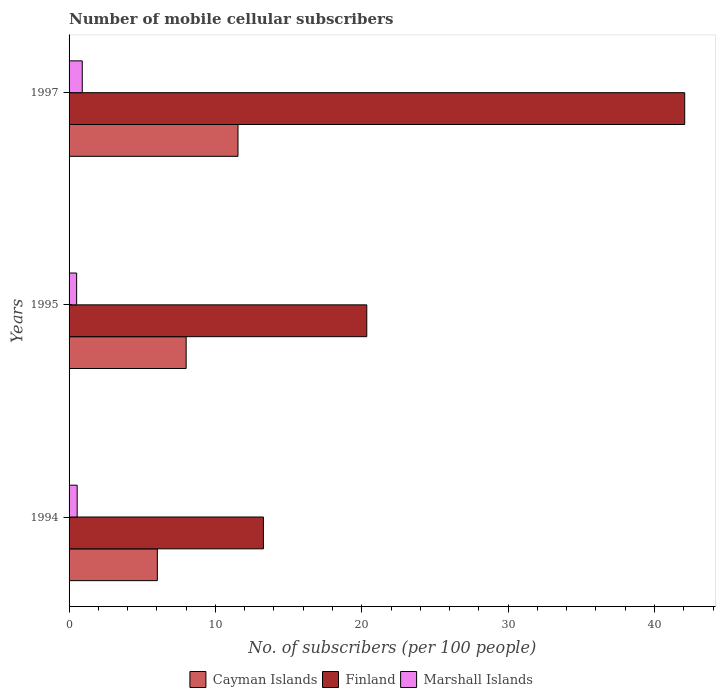Are the number of bars per tick equal to the number of legend labels?
Your answer should be very brief. Yes. How many bars are there on the 2nd tick from the top?
Give a very brief answer. 3. What is the number of mobile cellular subscribers in Marshall Islands in 1994?
Provide a short and direct response. 0.55. Across all years, what is the maximum number of mobile cellular subscribers in Finland?
Ensure brevity in your answer.  42.07. Across all years, what is the minimum number of mobile cellular subscribers in Finland?
Your answer should be compact. 13.28. What is the total number of mobile cellular subscribers in Finland in the graph?
Your answer should be very brief. 75.69. What is the difference between the number of mobile cellular subscribers in Finland in 1994 and that in 1997?
Your answer should be compact. -28.79. What is the difference between the number of mobile cellular subscribers in Marshall Islands in 1995 and the number of mobile cellular subscribers in Finland in 1997?
Offer a very short reply. -41.55. What is the average number of mobile cellular subscribers in Marshall Islands per year?
Your response must be concise. 0.66. In the year 1994, what is the difference between the number of mobile cellular subscribers in Cayman Islands and number of mobile cellular subscribers in Finland?
Your response must be concise. -7.25. In how many years, is the number of mobile cellular subscribers in Cayman Islands greater than 30 ?
Ensure brevity in your answer.  0. What is the ratio of the number of mobile cellular subscribers in Cayman Islands in 1995 to that in 1997?
Make the answer very short. 0.69. What is the difference between the highest and the second highest number of mobile cellular subscribers in Marshall Islands?
Give a very brief answer. 0.35. What is the difference between the highest and the lowest number of mobile cellular subscribers in Finland?
Provide a succinct answer. 28.79. In how many years, is the number of mobile cellular subscribers in Marshall Islands greater than the average number of mobile cellular subscribers in Marshall Islands taken over all years?
Offer a very short reply. 1. What does the 3rd bar from the top in 1995 represents?
Provide a short and direct response. Cayman Islands. What does the 1st bar from the bottom in 1994 represents?
Keep it short and to the point. Cayman Islands. How many bars are there?
Your answer should be very brief. 9. How many years are there in the graph?
Your answer should be compact. 3. Are the values on the major ticks of X-axis written in scientific E-notation?
Offer a very short reply. No. Does the graph contain any zero values?
Provide a short and direct response. No. Does the graph contain grids?
Your answer should be very brief. No. Where does the legend appear in the graph?
Your answer should be very brief. Bottom center. How many legend labels are there?
Give a very brief answer. 3. What is the title of the graph?
Make the answer very short. Number of mobile cellular subscribers. Does "Upper middle income" appear as one of the legend labels in the graph?
Your answer should be compact. No. What is the label or title of the X-axis?
Offer a terse response. No. of subscribers (per 100 people). What is the label or title of the Y-axis?
Offer a terse response. Years. What is the No. of subscribers (per 100 people) of Cayman Islands in 1994?
Your answer should be compact. 6.03. What is the No. of subscribers (per 100 people) in Finland in 1994?
Give a very brief answer. 13.28. What is the No. of subscribers (per 100 people) in Marshall Islands in 1994?
Offer a very short reply. 0.55. What is the No. of subscribers (per 100 people) in Cayman Islands in 1995?
Ensure brevity in your answer.  8. What is the No. of subscribers (per 100 people) in Finland in 1995?
Your response must be concise. 20.34. What is the No. of subscribers (per 100 people) in Marshall Islands in 1995?
Offer a terse response. 0.52. What is the No. of subscribers (per 100 people) in Cayman Islands in 1997?
Your answer should be very brief. 11.54. What is the No. of subscribers (per 100 people) in Finland in 1997?
Ensure brevity in your answer.  42.07. What is the No. of subscribers (per 100 people) in Marshall Islands in 1997?
Offer a terse response. 0.9. Across all years, what is the maximum No. of subscribers (per 100 people) in Cayman Islands?
Your answer should be compact. 11.54. Across all years, what is the maximum No. of subscribers (per 100 people) in Finland?
Your answer should be compact. 42.07. Across all years, what is the maximum No. of subscribers (per 100 people) in Marshall Islands?
Provide a short and direct response. 0.9. Across all years, what is the minimum No. of subscribers (per 100 people) of Cayman Islands?
Make the answer very short. 6.03. Across all years, what is the minimum No. of subscribers (per 100 people) in Finland?
Your answer should be compact. 13.28. Across all years, what is the minimum No. of subscribers (per 100 people) in Marshall Islands?
Provide a short and direct response. 0.52. What is the total No. of subscribers (per 100 people) of Cayman Islands in the graph?
Offer a terse response. 25.58. What is the total No. of subscribers (per 100 people) of Finland in the graph?
Your answer should be very brief. 75.69. What is the total No. of subscribers (per 100 people) of Marshall Islands in the graph?
Offer a very short reply. 1.97. What is the difference between the No. of subscribers (per 100 people) of Cayman Islands in 1994 and that in 1995?
Offer a terse response. -1.97. What is the difference between the No. of subscribers (per 100 people) of Finland in 1994 and that in 1995?
Keep it short and to the point. -7.06. What is the difference between the No. of subscribers (per 100 people) of Marshall Islands in 1994 and that in 1995?
Keep it short and to the point. 0.04. What is the difference between the No. of subscribers (per 100 people) of Cayman Islands in 1994 and that in 1997?
Give a very brief answer. -5.51. What is the difference between the No. of subscribers (per 100 people) in Finland in 1994 and that in 1997?
Offer a terse response. -28.79. What is the difference between the No. of subscribers (per 100 people) of Marshall Islands in 1994 and that in 1997?
Give a very brief answer. -0.35. What is the difference between the No. of subscribers (per 100 people) in Cayman Islands in 1995 and that in 1997?
Provide a short and direct response. -3.54. What is the difference between the No. of subscribers (per 100 people) of Finland in 1995 and that in 1997?
Offer a terse response. -21.72. What is the difference between the No. of subscribers (per 100 people) in Marshall Islands in 1995 and that in 1997?
Give a very brief answer. -0.38. What is the difference between the No. of subscribers (per 100 people) in Cayman Islands in 1994 and the No. of subscribers (per 100 people) in Finland in 1995?
Your answer should be very brief. -14.31. What is the difference between the No. of subscribers (per 100 people) of Cayman Islands in 1994 and the No. of subscribers (per 100 people) of Marshall Islands in 1995?
Your answer should be compact. 5.51. What is the difference between the No. of subscribers (per 100 people) of Finland in 1994 and the No. of subscribers (per 100 people) of Marshall Islands in 1995?
Your response must be concise. 12.76. What is the difference between the No. of subscribers (per 100 people) in Cayman Islands in 1994 and the No. of subscribers (per 100 people) in Finland in 1997?
Make the answer very short. -36.03. What is the difference between the No. of subscribers (per 100 people) of Cayman Islands in 1994 and the No. of subscribers (per 100 people) of Marshall Islands in 1997?
Ensure brevity in your answer.  5.13. What is the difference between the No. of subscribers (per 100 people) of Finland in 1994 and the No. of subscribers (per 100 people) of Marshall Islands in 1997?
Provide a short and direct response. 12.38. What is the difference between the No. of subscribers (per 100 people) of Cayman Islands in 1995 and the No. of subscribers (per 100 people) of Finland in 1997?
Offer a very short reply. -34.07. What is the difference between the No. of subscribers (per 100 people) in Cayman Islands in 1995 and the No. of subscribers (per 100 people) in Marshall Islands in 1997?
Provide a short and direct response. 7.1. What is the difference between the No. of subscribers (per 100 people) of Finland in 1995 and the No. of subscribers (per 100 people) of Marshall Islands in 1997?
Offer a terse response. 19.44. What is the average No. of subscribers (per 100 people) in Cayman Islands per year?
Offer a terse response. 8.53. What is the average No. of subscribers (per 100 people) in Finland per year?
Provide a succinct answer. 25.23. What is the average No. of subscribers (per 100 people) in Marshall Islands per year?
Make the answer very short. 0.66. In the year 1994, what is the difference between the No. of subscribers (per 100 people) in Cayman Islands and No. of subscribers (per 100 people) in Finland?
Keep it short and to the point. -7.25. In the year 1994, what is the difference between the No. of subscribers (per 100 people) in Cayman Islands and No. of subscribers (per 100 people) in Marshall Islands?
Offer a terse response. 5.48. In the year 1994, what is the difference between the No. of subscribers (per 100 people) in Finland and No. of subscribers (per 100 people) in Marshall Islands?
Your answer should be very brief. 12.73. In the year 1995, what is the difference between the No. of subscribers (per 100 people) in Cayman Islands and No. of subscribers (per 100 people) in Finland?
Provide a succinct answer. -12.34. In the year 1995, what is the difference between the No. of subscribers (per 100 people) in Cayman Islands and No. of subscribers (per 100 people) in Marshall Islands?
Your answer should be compact. 7.48. In the year 1995, what is the difference between the No. of subscribers (per 100 people) in Finland and No. of subscribers (per 100 people) in Marshall Islands?
Your answer should be compact. 19.82. In the year 1997, what is the difference between the No. of subscribers (per 100 people) of Cayman Islands and No. of subscribers (per 100 people) of Finland?
Your answer should be very brief. -30.52. In the year 1997, what is the difference between the No. of subscribers (per 100 people) in Cayman Islands and No. of subscribers (per 100 people) in Marshall Islands?
Offer a very short reply. 10.64. In the year 1997, what is the difference between the No. of subscribers (per 100 people) in Finland and No. of subscribers (per 100 people) in Marshall Islands?
Your answer should be compact. 41.17. What is the ratio of the No. of subscribers (per 100 people) in Cayman Islands in 1994 to that in 1995?
Offer a terse response. 0.75. What is the ratio of the No. of subscribers (per 100 people) in Finland in 1994 to that in 1995?
Your answer should be compact. 0.65. What is the ratio of the No. of subscribers (per 100 people) of Marshall Islands in 1994 to that in 1995?
Your response must be concise. 1.07. What is the ratio of the No. of subscribers (per 100 people) of Cayman Islands in 1994 to that in 1997?
Your answer should be very brief. 0.52. What is the ratio of the No. of subscribers (per 100 people) of Finland in 1994 to that in 1997?
Give a very brief answer. 0.32. What is the ratio of the No. of subscribers (per 100 people) of Marshall Islands in 1994 to that in 1997?
Give a very brief answer. 0.61. What is the ratio of the No. of subscribers (per 100 people) of Cayman Islands in 1995 to that in 1997?
Provide a succinct answer. 0.69. What is the ratio of the No. of subscribers (per 100 people) in Finland in 1995 to that in 1997?
Your answer should be very brief. 0.48. What is the ratio of the No. of subscribers (per 100 people) of Marshall Islands in 1995 to that in 1997?
Offer a very short reply. 0.57. What is the difference between the highest and the second highest No. of subscribers (per 100 people) in Cayman Islands?
Offer a terse response. 3.54. What is the difference between the highest and the second highest No. of subscribers (per 100 people) in Finland?
Offer a very short reply. 21.72. What is the difference between the highest and the second highest No. of subscribers (per 100 people) of Marshall Islands?
Your answer should be very brief. 0.35. What is the difference between the highest and the lowest No. of subscribers (per 100 people) of Cayman Islands?
Your answer should be very brief. 5.51. What is the difference between the highest and the lowest No. of subscribers (per 100 people) in Finland?
Offer a terse response. 28.79. What is the difference between the highest and the lowest No. of subscribers (per 100 people) of Marshall Islands?
Provide a succinct answer. 0.38. 